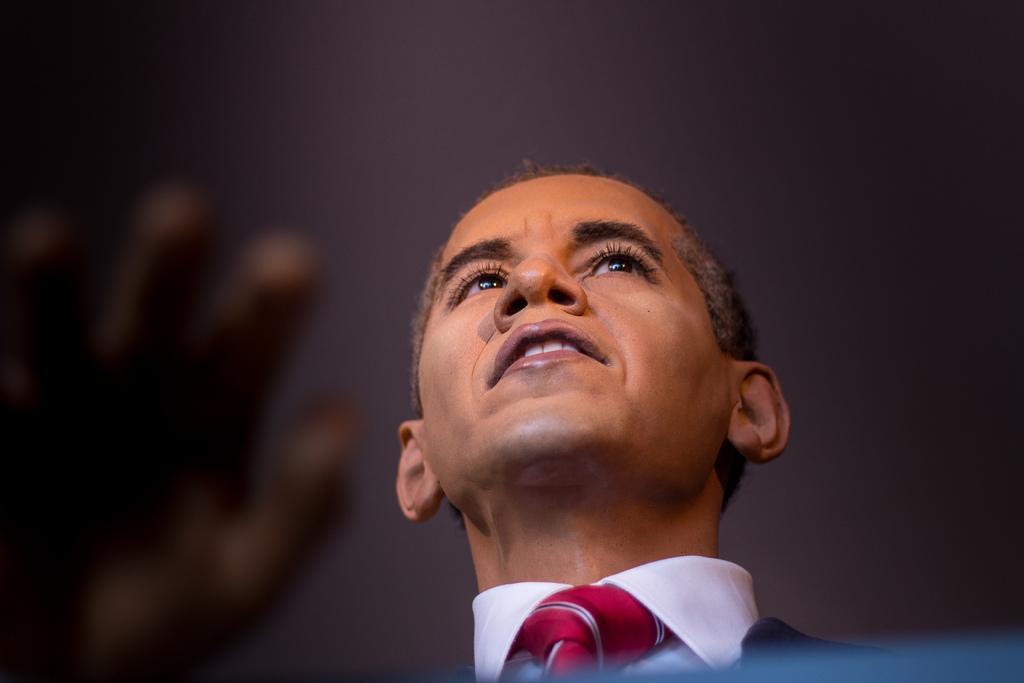In one or two sentences, can you explain what this image depicts? In the middle of the image we can see a person. Around the person it is blurry.  